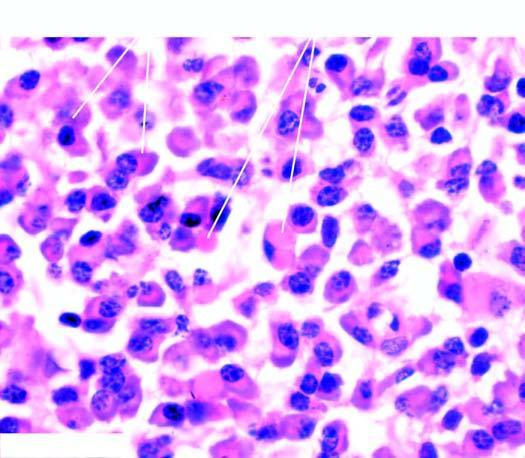what shows pink homogeneous globular material due to accumulated immunoglobulins?
Answer the question using a single word or phrase. The cytoplasm immunoglobulins 